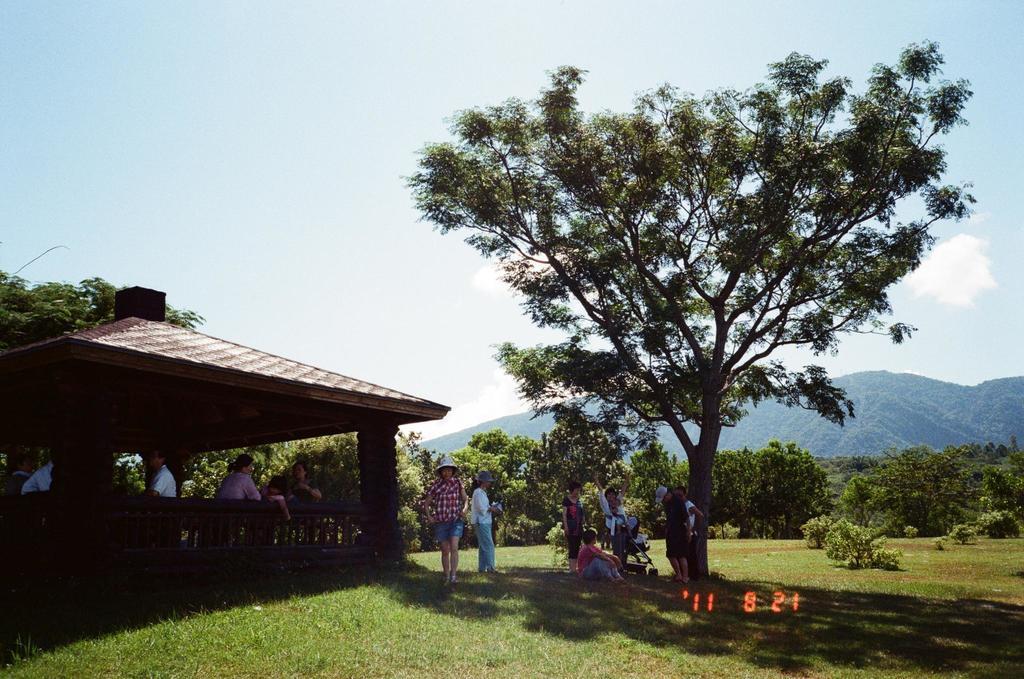In one or two sentences, can you explain what this image depicts? In this image there is grass, plants, group of people, gazebo, trees, hills, and in the background there is sky and a watermark on the image. 